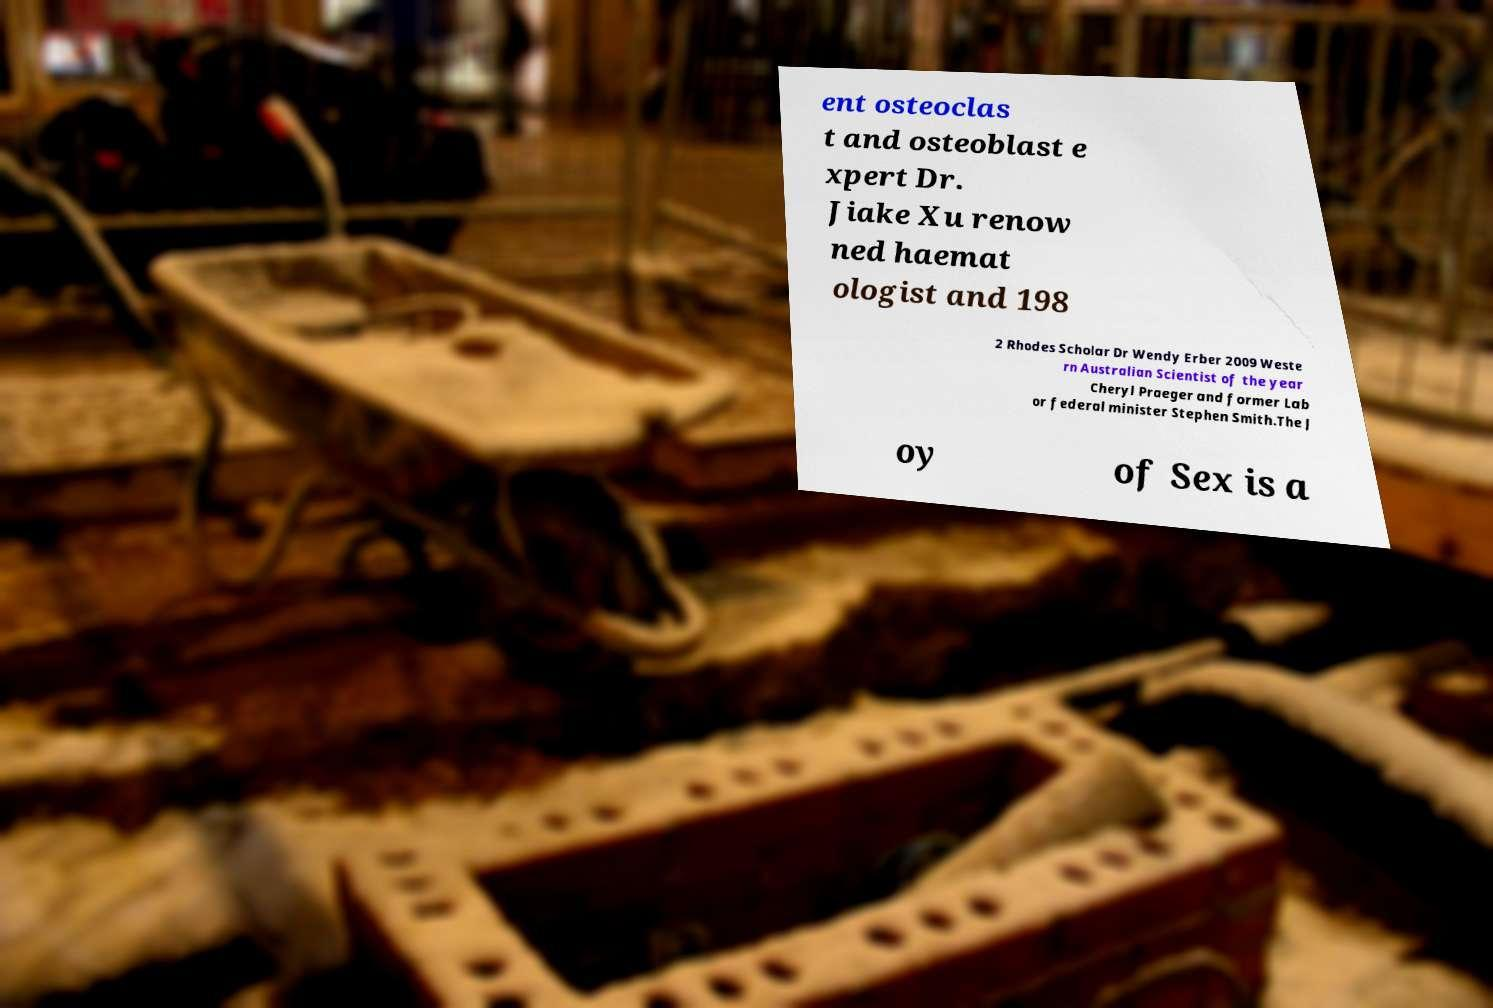Could you extract and type out the text from this image? ent osteoclas t and osteoblast e xpert Dr. Jiake Xu renow ned haemat ologist and 198 2 Rhodes Scholar Dr Wendy Erber 2009 Weste rn Australian Scientist of the year Cheryl Praeger and former Lab or federal minister Stephen Smith.The J oy of Sex is a 